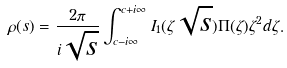Convert formula to latex. <formula><loc_0><loc_0><loc_500><loc_500>\rho ( s ) = \frac { 2 \pi } { i \sqrt { s } } \int _ { c - i \infty } ^ { c + i \infty } I _ { 1 } ( \zeta \sqrt { s } ) \Pi ( \zeta ) \zeta ^ { 2 } d \zeta .</formula> 